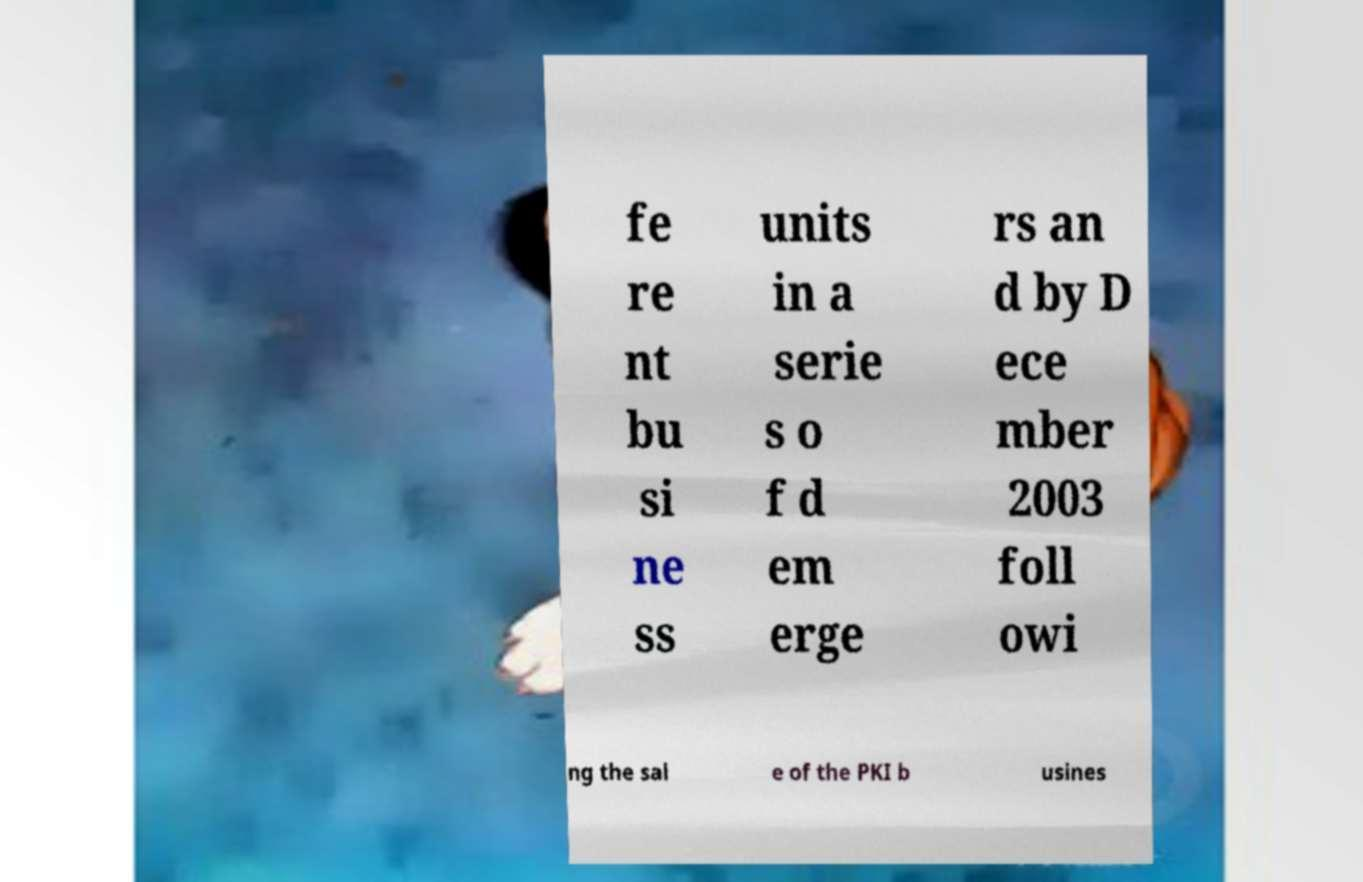Please read and relay the text visible in this image. What does it say? fe re nt bu si ne ss units in a serie s o f d em erge rs an d by D ece mber 2003 foll owi ng the sal e of the PKI b usines 